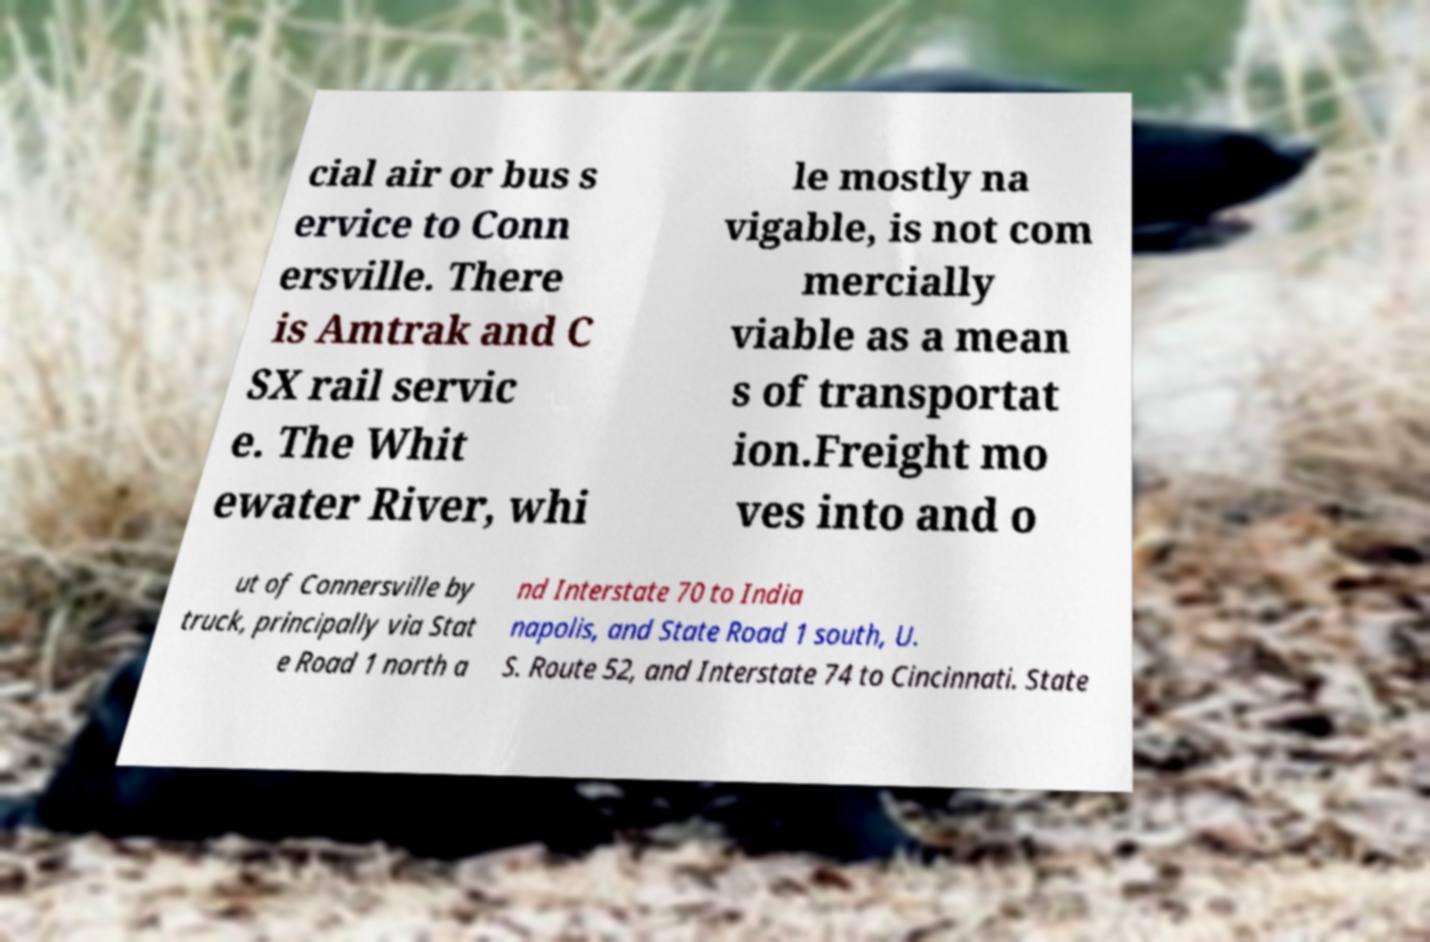Please identify and transcribe the text found in this image. cial air or bus s ervice to Conn ersville. There is Amtrak and C SX rail servic e. The Whit ewater River, whi le mostly na vigable, is not com mercially viable as a mean s of transportat ion.Freight mo ves into and o ut of Connersville by truck, principally via Stat e Road 1 north a nd Interstate 70 to India napolis, and State Road 1 south, U. S. Route 52, and Interstate 74 to Cincinnati. State 